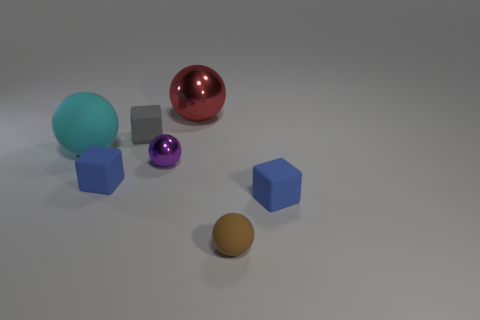Subtract 1 balls. How many balls are left? 3 Add 1 large purple metal cylinders. How many objects exist? 8 Subtract all blocks. How many objects are left? 4 Subtract 0 yellow balls. How many objects are left? 7 Subtract all green blocks. Subtract all small purple shiny spheres. How many objects are left? 6 Add 1 tiny brown rubber spheres. How many tiny brown rubber spheres are left? 2 Add 1 matte blocks. How many matte blocks exist? 4 